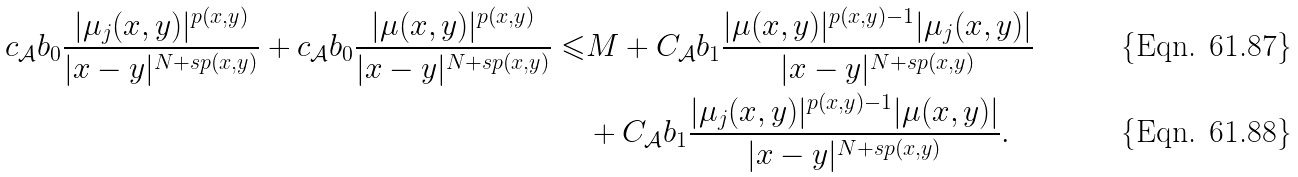Convert formula to latex. <formula><loc_0><loc_0><loc_500><loc_500>c _ { \mathcal { A } } b _ { 0 } \frac { | \mu _ { j } ( x , y ) | ^ { p ( x , y ) } } { | x - y | ^ { N + s p ( x , y ) } } + c _ { \mathcal { A } } b _ { 0 } \frac { | \mu ( x , y ) | ^ { p ( x , y ) } } { | x - y | ^ { N + s p ( x , y ) } } \leqslant & M + C _ { \mathcal { A } } b _ { 1 } \frac { | \mu ( x , y ) | ^ { p ( x , y ) - 1 } | \mu _ { j } ( x , y ) | } { | x - y | ^ { N + s p ( x , y ) } } \\ & + C _ { \mathcal { A } } b _ { 1 } \frac { | \mu _ { j } ( x , y ) | ^ { p ( x , y ) - 1 } | \mu ( x , y ) | } { | x - y | ^ { N + s p ( x , y ) } } .</formula> 